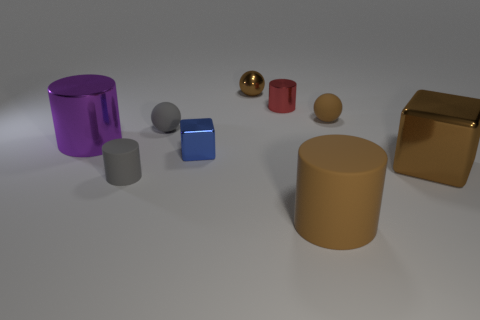Subtract all blocks. How many objects are left? 7 Add 9 large shiny cylinders. How many large shiny cylinders exist? 10 Subtract 1 gray balls. How many objects are left? 8 Subtract all big rubber objects. Subtract all tiny metal blocks. How many objects are left? 7 Add 4 gray matte objects. How many gray matte objects are left? 6 